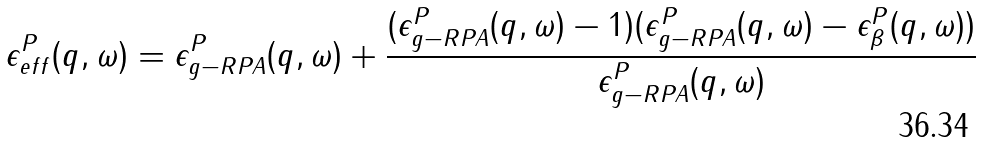<formula> <loc_0><loc_0><loc_500><loc_500>\epsilon ^ { P } _ { e f f } ( { q } , \omega ) = \epsilon ^ { P } _ { g - R P A } ( { q } , \omega ) + \frac { ( \epsilon ^ { P } _ { g - R P A } ( { q } , \omega ) - 1 ) ( \epsilon ^ { P } _ { g - R P A } ( { q } , \omega ) - \epsilon ^ { P } _ { \beta } ( { q } , \omega ) ) } { \epsilon ^ { P } _ { g - R P A } ( { q } , \omega ) }</formula> 